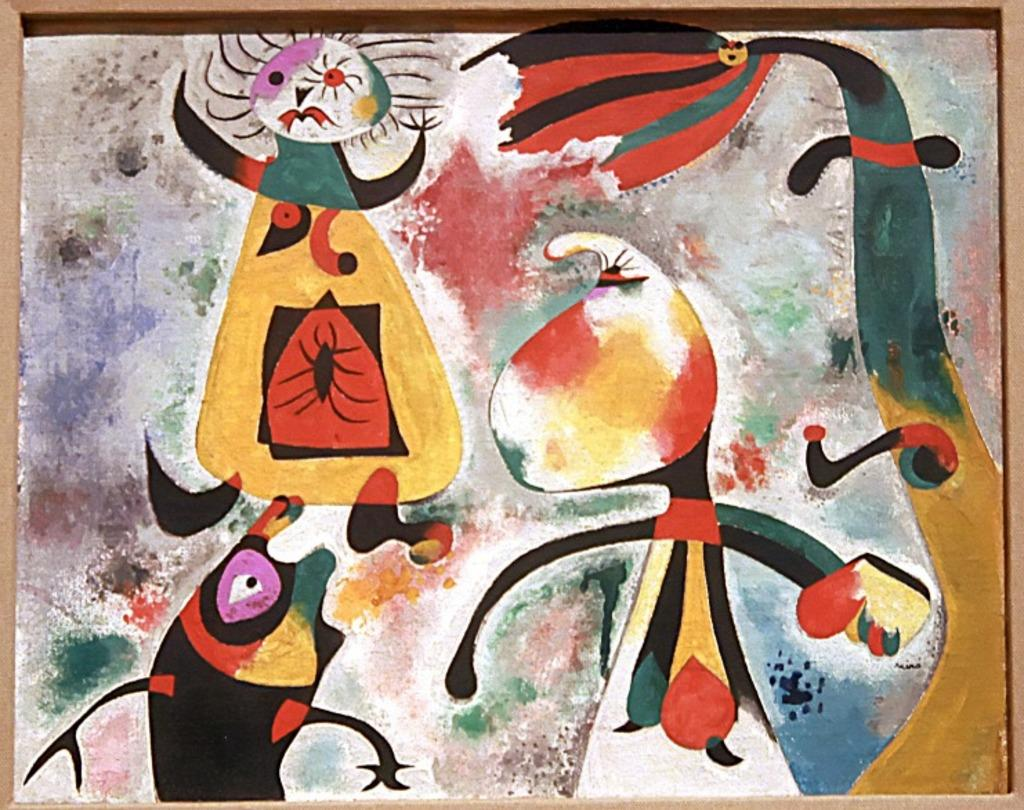What is the main object in the center of the image? There is a board in the center of the image. What is depicted on the board? There is a painting on the board. How many zebras are supporting the board in the image? There are no zebras present in the image, and they are not supporting the board. What type of parcel is being delivered on the board in the image? There is no parcel depicted on the board in the image; it features a painting. 